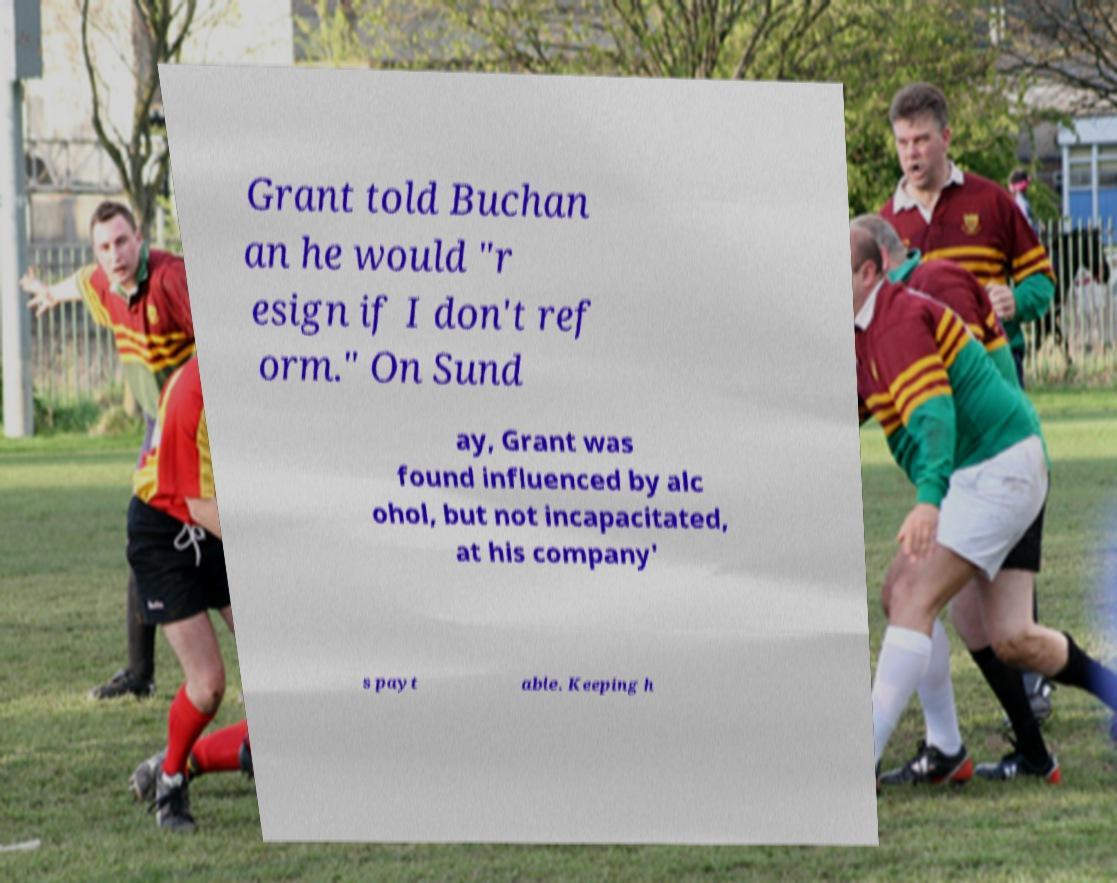There's text embedded in this image that I need extracted. Can you transcribe it verbatim? Grant told Buchan an he would "r esign if I don't ref orm." On Sund ay, Grant was found influenced by alc ohol, but not incapacitated, at his company' s payt able. Keeping h 